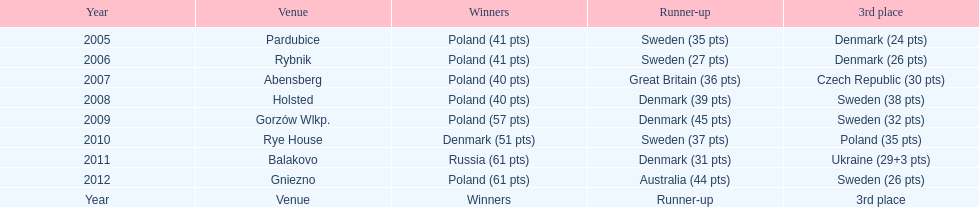Would you mind parsing the complete table? {'header': ['Year', 'Venue', 'Winners', 'Runner-up', '3rd place'], 'rows': [['2005', 'Pardubice', 'Poland (41 pts)', 'Sweden (35 pts)', 'Denmark (24 pts)'], ['2006', 'Rybnik', 'Poland (41 pts)', 'Sweden (27 pts)', 'Denmark (26 pts)'], ['2007', 'Abensberg', 'Poland (40 pts)', 'Great Britain (36 pts)', 'Czech Republic (30 pts)'], ['2008', 'Holsted', 'Poland (40 pts)', 'Denmark (39 pts)', 'Sweden (38 pts)'], ['2009', 'Gorzów Wlkp.', 'Poland (57 pts)', 'Denmark (45 pts)', 'Sweden (32 pts)'], ['2010', 'Rye House', 'Denmark (51 pts)', 'Sweden (37 pts)', 'Poland (35 pts)'], ['2011', 'Balakovo', 'Russia (61 pts)', 'Denmark (31 pts)', 'Ukraine (29+3 pts)'], ['2012', 'Gniezno', 'Poland (61 pts)', 'Australia (44 pts)', 'Sweden (26 pts)'], ['Year', 'Venue', 'Winners', 'Runner-up', '3rd place']]} Previous to 2008 how many times was sweden the runner up? 2. 